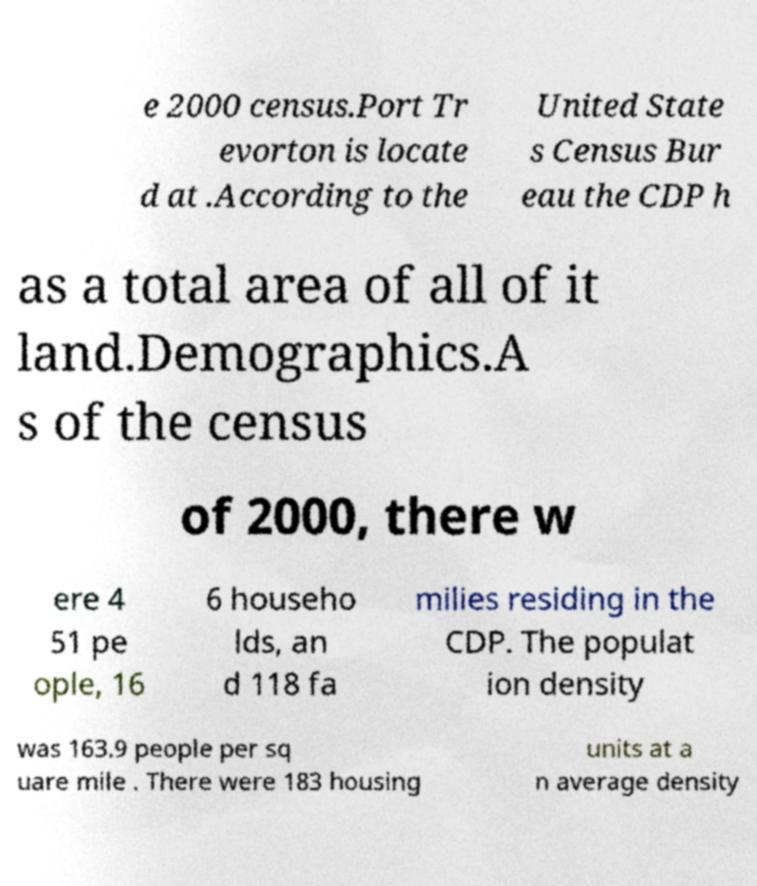There's text embedded in this image that I need extracted. Can you transcribe it verbatim? e 2000 census.Port Tr evorton is locate d at .According to the United State s Census Bur eau the CDP h as a total area of all of it land.Demographics.A s of the census of 2000, there w ere 4 51 pe ople, 16 6 househo lds, an d 118 fa milies residing in the CDP. The populat ion density was 163.9 people per sq uare mile . There were 183 housing units at a n average density 